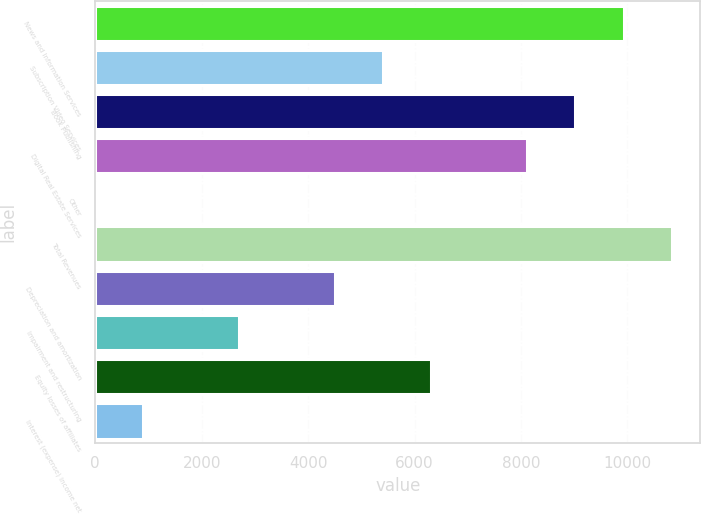Convert chart to OTSL. <chart><loc_0><loc_0><loc_500><loc_500><bar_chart><fcel>News and Information Services<fcel>Subscription Video Services<fcel>Book Publishing<fcel>Digital Real Estate Services<fcel>Other<fcel>Total Revenues<fcel>Depreciation and amortization<fcel>Impairment and restructuring<fcel>Equity losses of affiliates<fcel>Interest (expense) income net<nl><fcel>9926.2<fcel>5415.2<fcel>9024<fcel>8121.8<fcel>2<fcel>10828.4<fcel>4513<fcel>2708.6<fcel>6317.4<fcel>904.2<nl></chart> 